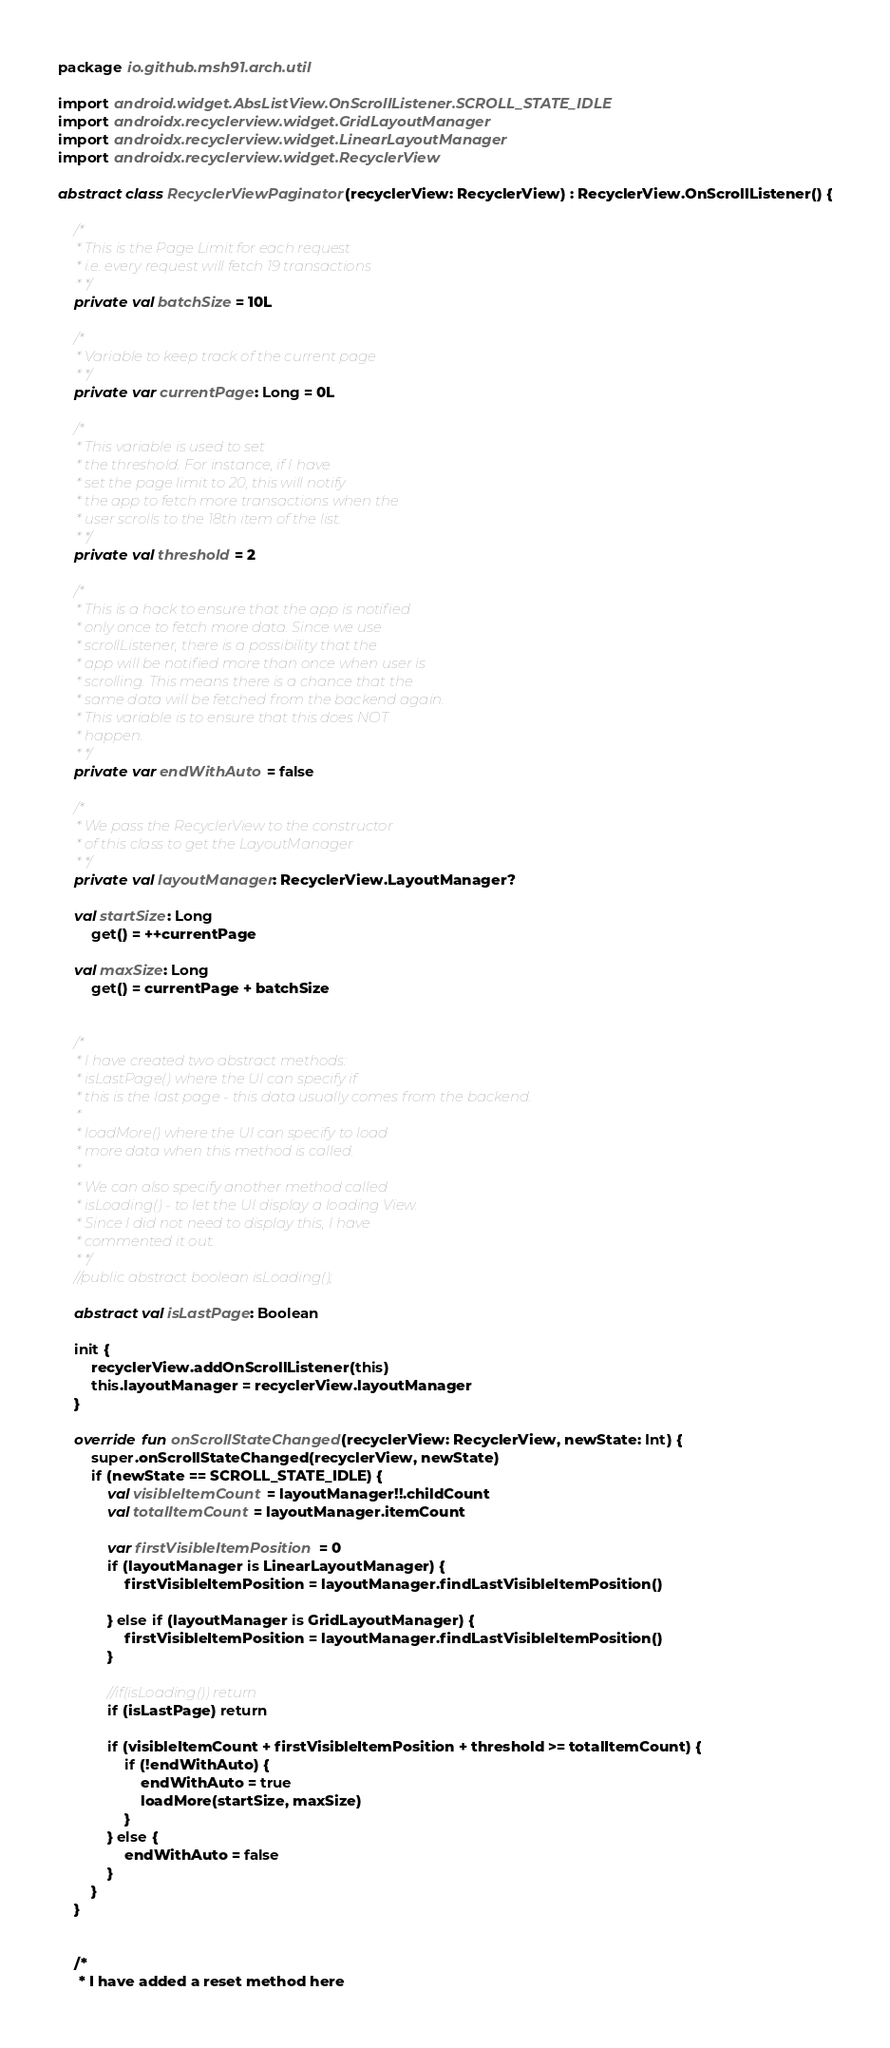Convert code to text. <code><loc_0><loc_0><loc_500><loc_500><_Kotlin_>package io.github.msh91.arch.util

import android.widget.AbsListView.OnScrollListener.SCROLL_STATE_IDLE
import androidx.recyclerview.widget.GridLayoutManager
import androidx.recyclerview.widget.LinearLayoutManager
import androidx.recyclerview.widget.RecyclerView

abstract class RecyclerViewPaginator(recyclerView: RecyclerView) : RecyclerView.OnScrollListener() {

    /*
     * This is the Page Limit for each request
     * i.e. every request will fetch 19 transactions
     * */
    private val batchSize = 10L

    /*
     * Variable to keep track of the current page
     * */
    private var currentPage: Long = 0L

    /*
     * This variable is used to set
     * the threshold. For instance, if I have
     * set the page limit to 20, this will notify
     * the app to fetch more transactions when the
     * user scrolls to the 18th item of the list.
     * */
    private val threshold = 2

    /*
     * This is a hack to ensure that the app is notified
     * only once to fetch more data. Since we use
     * scrollListener, there is a possibility that the
     * app will be notified more than once when user is
     * scrolling. This means there is a chance that the
     * same data will be fetched from the backend again.
     * This variable is to ensure that this does NOT
     * happen.
     * */
    private var endWithAuto = false

    /*
     * We pass the RecyclerView to the constructor
     * of this class to get the LayoutManager
     * */
    private val layoutManager: RecyclerView.LayoutManager?

    val startSize: Long
        get() = ++currentPage

    val maxSize: Long
        get() = currentPage + batchSize


    /*
     * I have created two abstract methods:
     * isLastPage() where the UI can specify if
     * this is the last page - this data usually comes from the backend.
     *
     * loadMore() where the UI can specify to load
     * more data when this method is called.
     *
     * We can also specify another method called
     * isLoading() - to let the UI display a loading View.
     * Since I did not need to display this, I have
     * commented it out.
     * */
    //public abstract boolean isLoading();

    abstract val isLastPage: Boolean

    init {
        recyclerView.addOnScrollListener(this)
        this.layoutManager = recyclerView.layoutManager
    }

    override fun onScrollStateChanged(recyclerView: RecyclerView, newState: Int) {
        super.onScrollStateChanged(recyclerView, newState)
        if (newState == SCROLL_STATE_IDLE) {
            val visibleItemCount = layoutManager!!.childCount
            val totalItemCount = layoutManager.itemCount

            var firstVisibleItemPosition = 0
            if (layoutManager is LinearLayoutManager) {
                firstVisibleItemPosition = layoutManager.findLastVisibleItemPosition()

            } else if (layoutManager is GridLayoutManager) {
                firstVisibleItemPosition = layoutManager.findLastVisibleItemPosition()
            }

            //if(isLoading()) return
            if (isLastPage) return

            if (visibleItemCount + firstVisibleItemPosition + threshold >= totalItemCount) {
                if (!endWithAuto) {
                    endWithAuto = true
                    loadMore(startSize, maxSize)
                }
            } else {
                endWithAuto = false
            }
        }
    }


    /*
     * I have added a reset method here</code> 